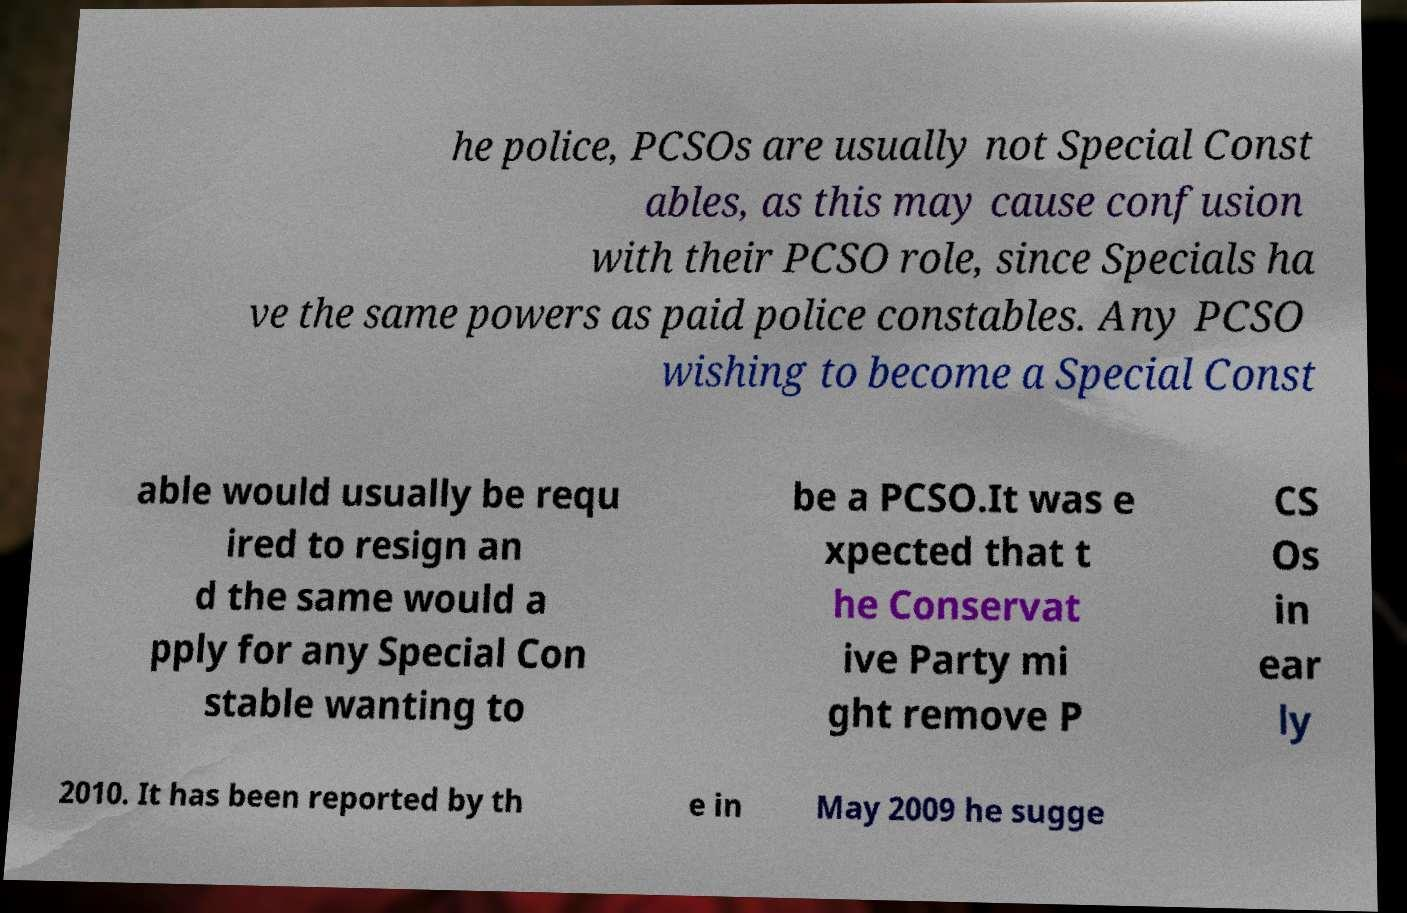For documentation purposes, I need the text within this image transcribed. Could you provide that? he police, PCSOs are usually not Special Const ables, as this may cause confusion with their PCSO role, since Specials ha ve the same powers as paid police constables. Any PCSO wishing to become a Special Const able would usually be requ ired to resign an d the same would a pply for any Special Con stable wanting to be a PCSO.It was e xpected that t he Conservat ive Party mi ght remove P CS Os in ear ly 2010. It has been reported by th e in May 2009 he sugge 